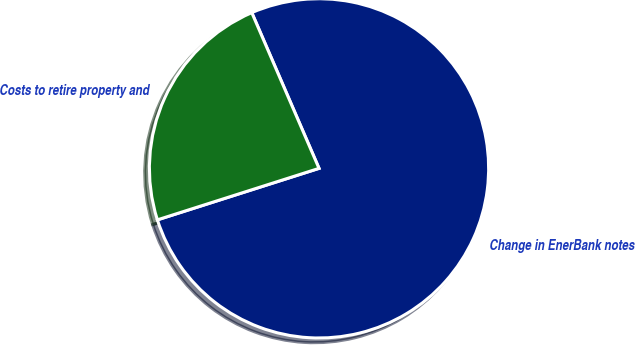Convert chart to OTSL. <chart><loc_0><loc_0><loc_500><loc_500><pie_chart><fcel>Change in EnerBank notes<fcel>Costs to retire property and<nl><fcel>76.58%<fcel>23.42%<nl></chart> 